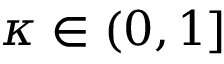Convert formula to latex. <formula><loc_0><loc_0><loc_500><loc_500>\kappa \in ( 0 , 1 ]</formula> 